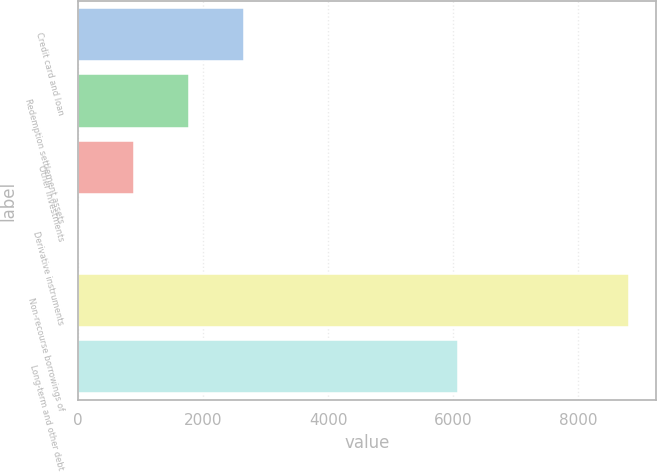Convert chart. <chart><loc_0><loc_0><loc_500><loc_500><bar_chart><fcel>Credit card and loan<fcel>Redemption settlement assets<fcel>Other investments<fcel>Derivative instruments<fcel>Non-recourse borrowings of<fcel>Long-term and other debt<nl><fcel>2653.39<fcel>1774.26<fcel>895.13<fcel>16<fcel>8807.3<fcel>6079.6<nl></chart> 